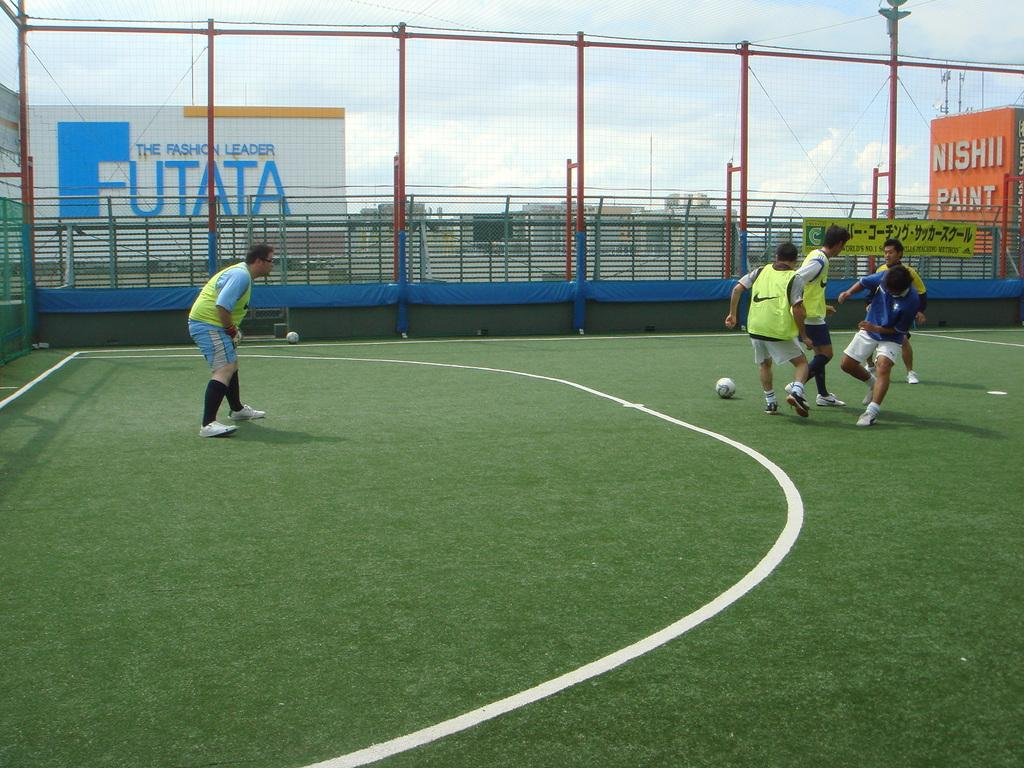<image>
Relay a brief, clear account of the picture shown. A large sign behind the soccer field says that Futata is the fashion leader. 